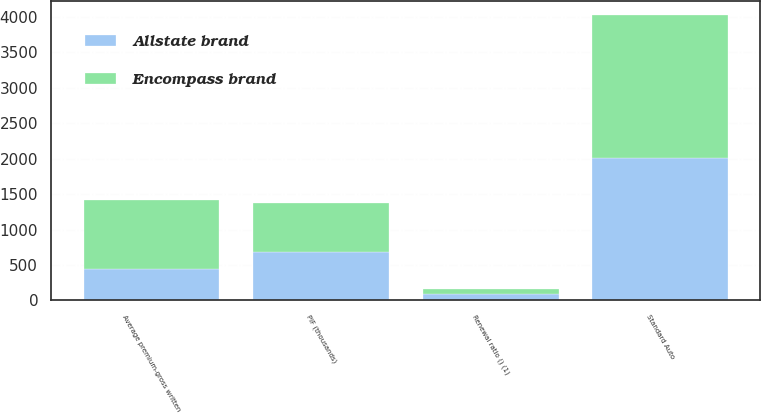<chart> <loc_0><loc_0><loc_500><loc_500><stacked_bar_chart><ecel><fcel>Standard Auto<fcel>PIF (thousands)<fcel>Average premium-gross written<fcel>Renewal ratio () (1)<nl><fcel>Allstate brand<fcel>2010<fcel>689<fcel>443<fcel>88.7<nl><fcel>Encompass brand<fcel>2010<fcel>689<fcel>979<fcel>69.2<nl></chart> 